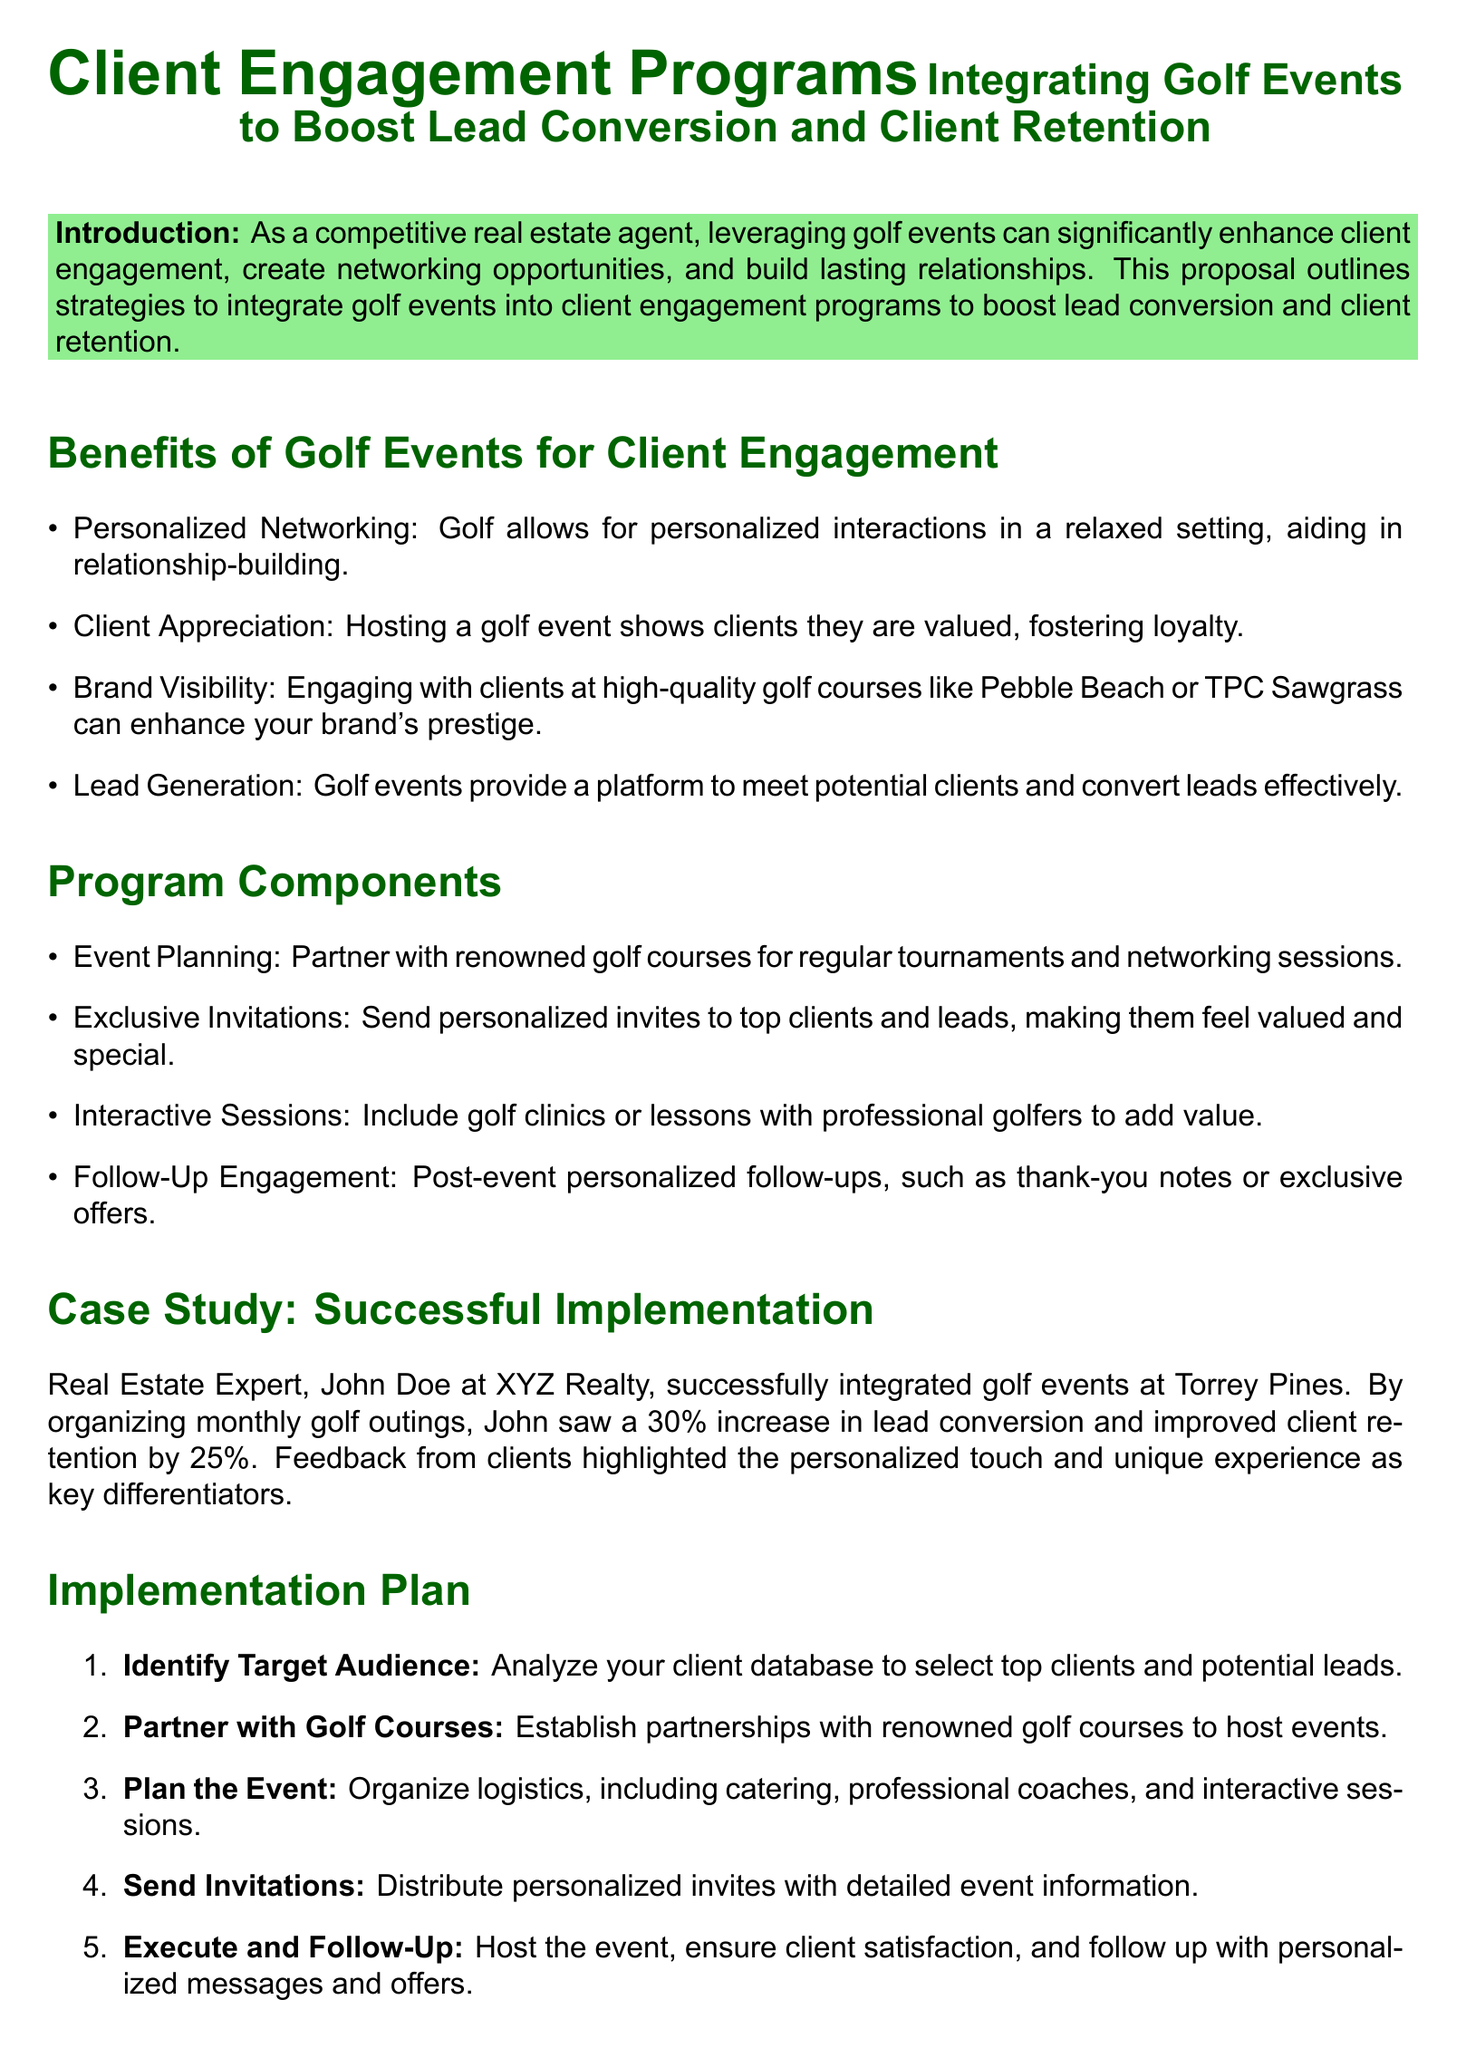What is the primary purpose of integrating golf events into client engagement programs? The proposal states that the primary purpose is to boost lead conversion and client retention.
Answer: Boost lead conversion and client retention Who is the real estate expert mentioned in the case study? The document mentions John Doe as the real estate expert.
Answer: John Doe What percentage increase in lead conversion did John Doe achieve? The document states that John saw a 30% increase in lead conversion.
Answer: 30% Name one benefit of hosting golf events according to the proposal. The document lists several benefits, one of which is personalized networking.
Answer: Personalized networking How many steps are in the implementation plan? The implementation plan consists of five steps in total.
Answer: Five steps What type of interactive activity is suggested to include during the golf events? The proposal suggests including golf clinics or lessons with professional golfers.
Answer: Golf clinics or lessons What was the improvement in client retention for John Doe? The proposal indicates that John improved client retention by 25%.
Answer: 25% What color is used for the introduction background? The introduction background color is light green.
Answer: Light green What is the title of the proposal? The title is "Client Engagement Programs Integrating Golf Events to Boost Lead Conversion and Client Retention."
Answer: Client Engagement Programs Integrating Golf Events to Boost Lead Conversion and Client Retention 